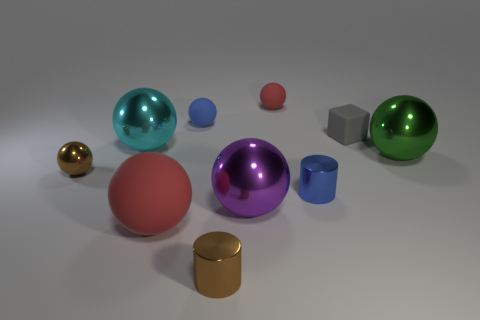Subtract all cyan balls. How many balls are left? 6 Subtract all cyan shiny balls. How many balls are left? 6 Subtract all red spheres. Subtract all gray cubes. How many spheres are left? 5 Subtract all spheres. How many objects are left? 3 Add 1 brown cylinders. How many brown cylinders are left? 2 Add 2 shiny objects. How many shiny objects exist? 8 Subtract 1 red spheres. How many objects are left? 9 Subtract all big cyan metal spheres. Subtract all big matte objects. How many objects are left? 8 